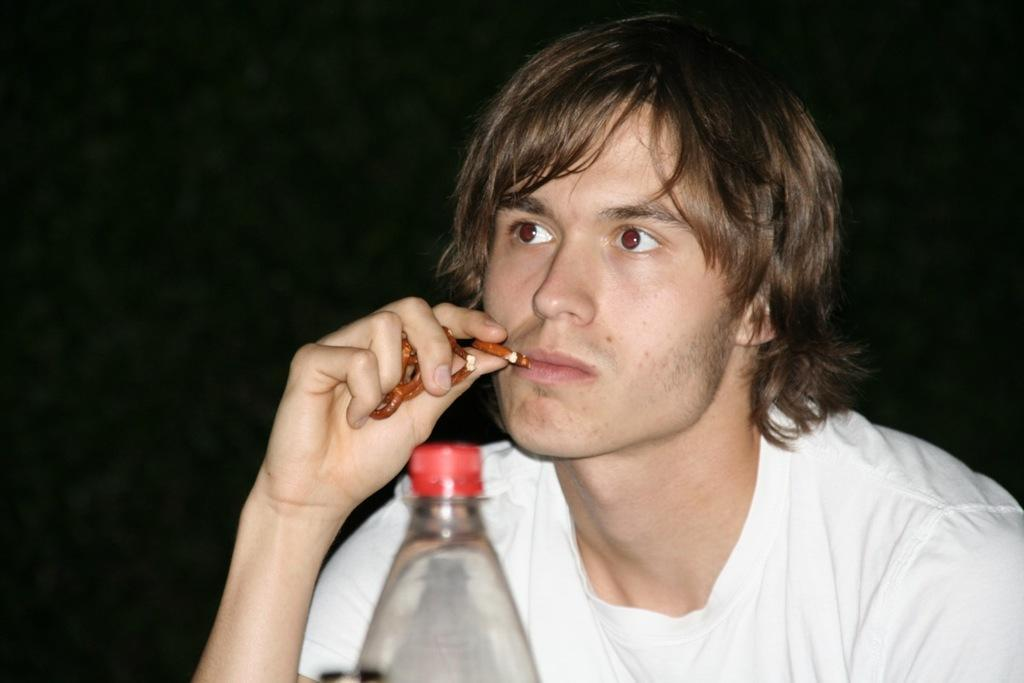Who is present in the image? There is a man in the image. What is the man holding in his hand? The man is holding food items in his hand. What object is in front of the man? There is a bottle in front of the man. What is the color of the background in the image? The background of the image is black. What type of silk material is draped over the seat in the image? There is no silk material or seat present in the image. What arithmetic problem is the man solving in the image? There is no arithmetic problem visible in the image. 